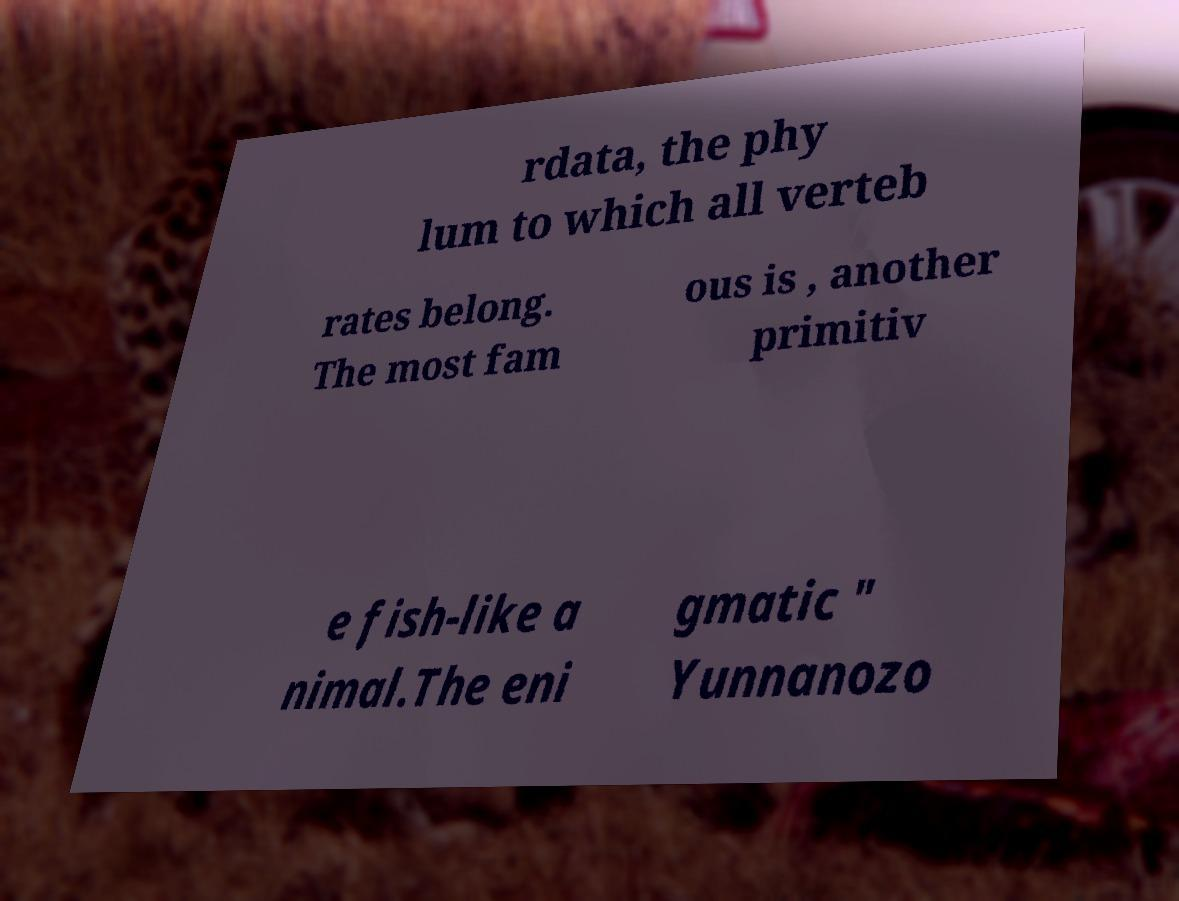Can you read and provide the text displayed in the image?This photo seems to have some interesting text. Can you extract and type it out for me? rdata, the phy lum to which all verteb rates belong. The most fam ous is , another primitiv e fish-like a nimal.The eni gmatic " Yunnanozo 